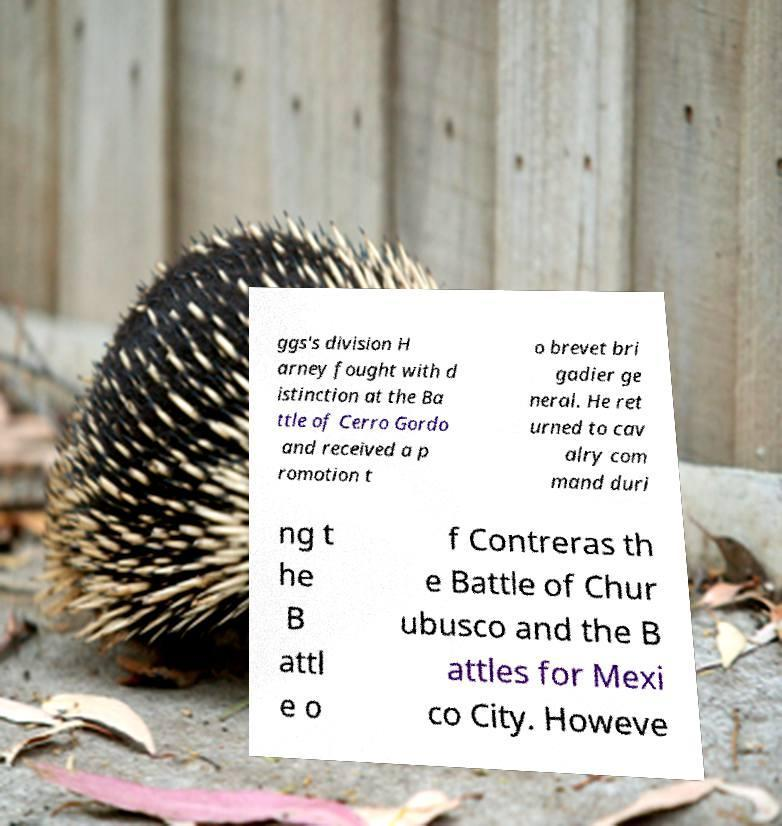For documentation purposes, I need the text within this image transcribed. Could you provide that? ggs's division H arney fought with d istinction at the Ba ttle of Cerro Gordo and received a p romotion t o brevet bri gadier ge neral. He ret urned to cav alry com mand duri ng t he B attl e o f Contreras th e Battle of Chur ubusco and the B attles for Mexi co City. Howeve 